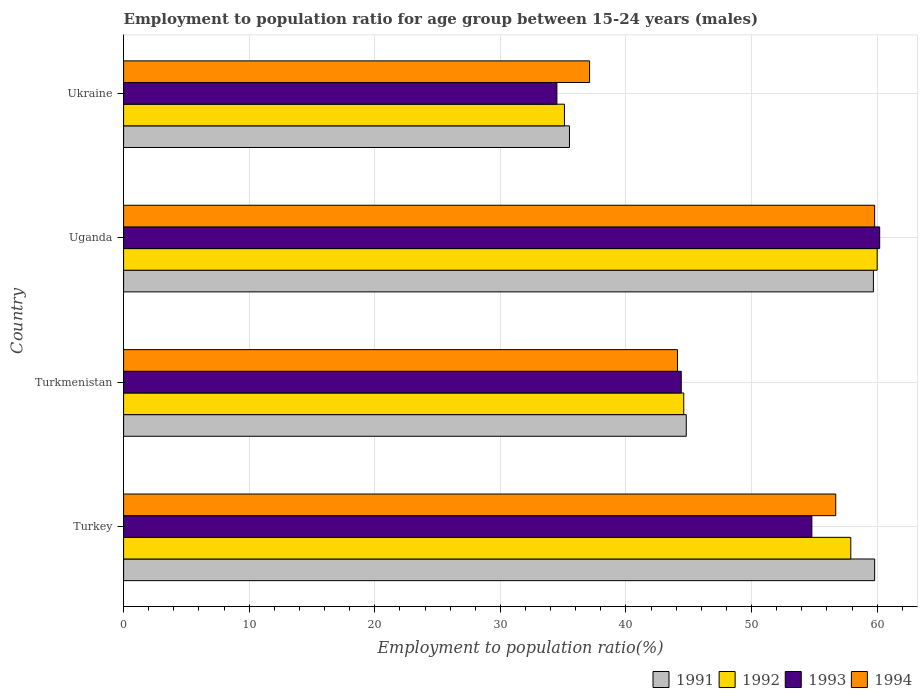Are the number of bars per tick equal to the number of legend labels?
Ensure brevity in your answer.  Yes. How many bars are there on the 4th tick from the top?
Offer a terse response. 4. How many bars are there on the 3rd tick from the bottom?
Your answer should be very brief. 4. What is the label of the 2nd group of bars from the top?
Your answer should be very brief. Uganda. In how many cases, is the number of bars for a given country not equal to the number of legend labels?
Give a very brief answer. 0. What is the employment to population ratio in 1992 in Turkmenistan?
Your answer should be compact. 44.6. Across all countries, what is the maximum employment to population ratio in 1992?
Keep it short and to the point. 60. Across all countries, what is the minimum employment to population ratio in 1991?
Provide a short and direct response. 35.5. In which country was the employment to population ratio in 1994 maximum?
Provide a succinct answer. Uganda. In which country was the employment to population ratio in 1991 minimum?
Your response must be concise. Ukraine. What is the total employment to population ratio in 1991 in the graph?
Your answer should be very brief. 199.8. What is the difference between the employment to population ratio in 1991 in Turkmenistan and that in Ukraine?
Offer a terse response. 9.3. What is the difference between the employment to population ratio in 1991 in Uganda and the employment to population ratio in 1994 in Turkmenistan?
Your response must be concise. 15.6. What is the average employment to population ratio in 1993 per country?
Your answer should be very brief. 48.48. What is the ratio of the employment to population ratio in 1991 in Turkey to that in Turkmenistan?
Ensure brevity in your answer.  1.33. Is the difference between the employment to population ratio in 1992 in Turkmenistan and Ukraine greater than the difference between the employment to population ratio in 1994 in Turkmenistan and Ukraine?
Keep it short and to the point. Yes. What is the difference between the highest and the second highest employment to population ratio in 1991?
Give a very brief answer. 0.1. What is the difference between the highest and the lowest employment to population ratio in 1992?
Provide a succinct answer. 24.9. In how many countries, is the employment to population ratio in 1993 greater than the average employment to population ratio in 1993 taken over all countries?
Your response must be concise. 2. Is the sum of the employment to population ratio in 1993 in Turkey and Uganda greater than the maximum employment to population ratio in 1992 across all countries?
Make the answer very short. Yes. Is it the case that in every country, the sum of the employment to population ratio in 1994 and employment to population ratio in 1992 is greater than the sum of employment to population ratio in 1991 and employment to population ratio in 1993?
Give a very brief answer. No. How many bars are there?
Give a very brief answer. 16. How many countries are there in the graph?
Give a very brief answer. 4. Are the values on the major ticks of X-axis written in scientific E-notation?
Your response must be concise. No. Does the graph contain any zero values?
Keep it short and to the point. No. Does the graph contain grids?
Ensure brevity in your answer.  Yes. Where does the legend appear in the graph?
Provide a short and direct response. Bottom right. How many legend labels are there?
Your answer should be very brief. 4. What is the title of the graph?
Offer a very short reply. Employment to population ratio for age group between 15-24 years (males). What is the label or title of the X-axis?
Provide a short and direct response. Employment to population ratio(%). What is the Employment to population ratio(%) of 1991 in Turkey?
Your answer should be very brief. 59.8. What is the Employment to population ratio(%) of 1992 in Turkey?
Your answer should be very brief. 57.9. What is the Employment to population ratio(%) in 1993 in Turkey?
Keep it short and to the point. 54.8. What is the Employment to population ratio(%) of 1994 in Turkey?
Provide a succinct answer. 56.7. What is the Employment to population ratio(%) in 1991 in Turkmenistan?
Make the answer very short. 44.8. What is the Employment to population ratio(%) in 1992 in Turkmenistan?
Provide a short and direct response. 44.6. What is the Employment to population ratio(%) of 1993 in Turkmenistan?
Your answer should be compact. 44.4. What is the Employment to population ratio(%) of 1994 in Turkmenistan?
Offer a terse response. 44.1. What is the Employment to population ratio(%) of 1991 in Uganda?
Your answer should be very brief. 59.7. What is the Employment to population ratio(%) of 1992 in Uganda?
Ensure brevity in your answer.  60. What is the Employment to population ratio(%) in 1993 in Uganda?
Your response must be concise. 60.2. What is the Employment to population ratio(%) of 1994 in Uganda?
Make the answer very short. 59.8. What is the Employment to population ratio(%) in 1991 in Ukraine?
Give a very brief answer. 35.5. What is the Employment to population ratio(%) in 1992 in Ukraine?
Offer a terse response. 35.1. What is the Employment to population ratio(%) in 1993 in Ukraine?
Make the answer very short. 34.5. What is the Employment to population ratio(%) of 1994 in Ukraine?
Ensure brevity in your answer.  37.1. Across all countries, what is the maximum Employment to population ratio(%) in 1991?
Provide a short and direct response. 59.8. Across all countries, what is the maximum Employment to population ratio(%) in 1992?
Offer a very short reply. 60. Across all countries, what is the maximum Employment to population ratio(%) in 1993?
Your answer should be very brief. 60.2. Across all countries, what is the maximum Employment to population ratio(%) of 1994?
Make the answer very short. 59.8. Across all countries, what is the minimum Employment to population ratio(%) of 1991?
Your response must be concise. 35.5. Across all countries, what is the minimum Employment to population ratio(%) in 1992?
Make the answer very short. 35.1. Across all countries, what is the minimum Employment to population ratio(%) of 1993?
Provide a short and direct response. 34.5. Across all countries, what is the minimum Employment to population ratio(%) of 1994?
Ensure brevity in your answer.  37.1. What is the total Employment to population ratio(%) of 1991 in the graph?
Provide a short and direct response. 199.8. What is the total Employment to population ratio(%) in 1992 in the graph?
Provide a short and direct response. 197.6. What is the total Employment to population ratio(%) in 1993 in the graph?
Offer a terse response. 193.9. What is the total Employment to population ratio(%) of 1994 in the graph?
Make the answer very short. 197.7. What is the difference between the Employment to population ratio(%) of 1992 in Turkey and that in Turkmenistan?
Give a very brief answer. 13.3. What is the difference between the Employment to population ratio(%) of 1993 in Turkey and that in Turkmenistan?
Make the answer very short. 10.4. What is the difference between the Employment to population ratio(%) in 1992 in Turkey and that in Uganda?
Offer a terse response. -2.1. What is the difference between the Employment to population ratio(%) of 1993 in Turkey and that in Uganda?
Your response must be concise. -5.4. What is the difference between the Employment to population ratio(%) in 1991 in Turkey and that in Ukraine?
Your answer should be compact. 24.3. What is the difference between the Employment to population ratio(%) of 1992 in Turkey and that in Ukraine?
Provide a short and direct response. 22.8. What is the difference between the Employment to population ratio(%) of 1993 in Turkey and that in Ukraine?
Provide a short and direct response. 20.3. What is the difference between the Employment to population ratio(%) of 1994 in Turkey and that in Ukraine?
Provide a short and direct response. 19.6. What is the difference between the Employment to population ratio(%) in 1991 in Turkmenistan and that in Uganda?
Offer a terse response. -14.9. What is the difference between the Employment to population ratio(%) of 1992 in Turkmenistan and that in Uganda?
Ensure brevity in your answer.  -15.4. What is the difference between the Employment to population ratio(%) of 1993 in Turkmenistan and that in Uganda?
Offer a terse response. -15.8. What is the difference between the Employment to population ratio(%) in 1994 in Turkmenistan and that in Uganda?
Your response must be concise. -15.7. What is the difference between the Employment to population ratio(%) in 1994 in Turkmenistan and that in Ukraine?
Your answer should be compact. 7. What is the difference between the Employment to population ratio(%) of 1991 in Uganda and that in Ukraine?
Provide a short and direct response. 24.2. What is the difference between the Employment to population ratio(%) of 1992 in Uganda and that in Ukraine?
Give a very brief answer. 24.9. What is the difference between the Employment to population ratio(%) of 1993 in Uganda and that in Ukraine?
Offer a very short reply. 25.7. What is the difference between the Employment to population ratio(%) in 1994 in Uganda and that in Ukraine?
Offer a very short reply. 22.7. What is the difference between the Employment to population ratio(%) of 1991 in Turkey and the Employment to population ratio(%) of 1992 in Turkmenistan?
Provide a succinct answer. 15.2. What is the difference between the Employment to population ratio(%) of 1991 in Turkey and the Employment to population ratio(%) of 1993 in Turkmenistan?
Give a very brief answer. 15.4. What is the difference between the Employment to population ratio(%) of 1991 in Turkey and the Employment to population ratio(%) of 1994 in Turkmenistan?
Your answer should be compact. 15.7. What is the difference between the Employment to population ratio(%) in 1992 in Turkey and the Employment to population ratio(%) in 1993 in Turkmenistan?
Ensure brevity in your answer.  13.5. What is the difference between the Employment to population ratio(%) in 1991 in Turkey and the Employment to population ratio(%) in 1993 in Uganda?
Provide a succinct answer. -0.4. What is the difference between the Employment to population ratio(%) in 1991 in Turkey and the Employment to population ratio(%) in 1994 in Uganda?
Keep it short and to the point. 0. What is the difference between the Employment to population ratio(%) of 1992 in Turkey and the Employment to population ratio(%) of 1993 in Uganda?
Make the answer very short. -2.3. What is the difference between the Employment to population ratio(%) of 1992 in Turkey and the Employment to population ratio(%) of 1994 in Uganda?
Your answer should be very brief. -1.9. What is the difference between the Employment to population ratio(%) of 1991 in Turkey and the Employment to population ratio(%) of 1992 in Ukraine?
Provide a succinct answer. 24.7. What is the difference between the Employment to population ratio(%) of 1991 in Turkey and the Employment to population ratio(%) of 1993 in Ukraine?
Keep it short and to the point. 25.3. What is the difference between the Employment to population ratio(%) in 1991 in Turkey and the Employment to population ratio(%) in 1994 in Ukraine?
Your answer should be compact. 22.7. What is the difference between the Employment to population ratio(%) in 1992 in Turkey and the Employment to population ratio(%) in 1993 in Ukraine?
Offer a very short reply. 23.4. What is the difference between the Employment to population ratio(%) of 1992 in Turkey and the Employment to population ratio(%) of 1994 in Ukraine?
Ensure brevity in your answer.  20.8. What is the difference between the Employment to population ratio(%) of 1991 in Turkmenistan and the Employment to population ratio(%) of 1992 in Uganda?
Your response must be concise. -15.2. What is the difference between the Employment to population ratio(%) of 1991 in Turkmenistan and the Employment to population ratio(%) of 1993 in Uganda?
Provide a succinct answer. -15.4. What is the difference between the Employment to population ratio(%) of 1991 in Turkmenistan and the Employment to population ratio(%) of 1994 in Uganda?
Offer a terse response. -15. What is the difference between the Employment to population ratio(%) in 1992 in Turkmenistan and the Employment to population ratio(%) in 1993 in Uganda?
Your response must be concise. -15.6. What is the difference between the Employment to population ratio(%) in 1992 in Turkmenistan and the Employment to population ratio(%) in 1994 in Uganda?
Your answer should be very brief. -15.2. What is the difference between the Employment to population ratio(%) in 1993 in Turkmenistan and the Employment to population ratio(%) in 1994 in Uganda?
Your answer should be very brief. -15.4. What is the difference between the Employment to population ratio(%) of 1991 in Turkmenistan and the Employment to population ratio(%) of 1992 in Ukraine?
Give a very brief answer. 9.7. What is the difference between the Employment to population ratio(%) in 1991 in Turkmenistan and the Employment to population ratio(%) in 1993 in Ukraine?
Your response must be concise. 10.3. What is the difference between the Employment to population ratio(%) in 1993 in Turkmenistan and the Employment to population ratio(%) in 1994 in Ukraine?
Your answer should be compact. 7.3. What is the difference between the Employment to population ratio(%) of 1991 in Uganda and the Employment to population ratio(%) of 1992 in Ukraine?
Make the answer very short. 24.6. What is the difference between the Employment to population ratio(%) in 1991 in Uganda and the Employment to population ratio(%) in 1993 in Ukraine?
Make the answer very short. 25.2. What is the difference between the Employment to population ratio(%) in 1991 in Uganda and the Employment to population ratio(%) in 1994 in Ukraine?
Offer a very short reply. 22.6. What is the difference between the Employment to population ratio(%) in 1992 in Uganda and the Employment to population ratio(%) in 1993 in Ukraine?
Your answer should be compact. 25.5. What is the difference between the Employment to population ratio(%) in 1992 in Uganda and the Employment to population ratio(%) in 1994 in Ukraine?
Your answer should be compact. 22.9. What is the difference between the Employment to population ratio(%) in 1993 in Uganda and the Employment to population ratio(%) in 1994 in Ukraine?
Your answer should be very brief. 23.1. What is the average Employment to population ratio(%) in 1991 per country?
Your answer should be compact. 49.95. What is the average Employment to population ratio(%) in 1992 per country?
Your response must be concise. 49.4. What is the average Employment to population ratio(%) in 1993 per country?
Your response must be concise. 48.48. What is the average Employment to population ratio(%) of 1994 per country?
Offer a very short reply. 49.42. What is the difference between the Employment to population ratio(%) in 1991 and Employment to population ratio(%) in 1993 in Turkey?
Your answer should be very brief. 5. What is the difference between the Employment to population ratio(%) in 1991 and Employment to population ratio(%) in 1994 in Turkey?
Your response must be concise. 3.1. What is the difference between the Employment to population ratio(%) in 1992 and Employment to population ratio(%) in 1993 in Turkey?
Your answer should be compact. 3.1. What is the difference between the Employment to population ratio(%) of 1991 and Employment to population ratio(%) of 1993 in Turkmenistan?
Ensure brevity in your answer.  0.4. What is the difference between the Employment to population ratio(%) of 1991 and Employment to population ratio(%) of 1994 in Turkmenistan?
Make the answer very short. 0.7. What is the difference between the Employment to population ratio(%) in 1992 and Employment to population ratio(%) in 1993 in Turkmenistan?
Keep it short and to the point. 0.2. What is the difference between the Employment to population ratio(%) in 1993 and Employment to population ratio(%) in 1994 in Turkmenistan?
Provide a short and direct response. 0.3. What is the difference between the Employment to population ratio(%) of 1991 and Employment to population ratio(%) of 1993 in Uganda?
Ensure brevity in your answer.  -0.5. What is the difference between the Employment to population ratio(%) of 1991 and Employment to population ratio(%) of 1992 in Ukraine?
Provide a short and direct response. 0.4. What is the difference between the Employment to population ratio(%) in 1991 and Employment to population ratio(%) in 1993 in Ukraine?
Keep it short and to the point. 1. What is the difference between the Employment to population ratio(%) of 1992 and Employment to population ratio(%) of 1994 in Ukraine?
Make the answer very short. -2. What is the difference between the Employment to population ratio(%) in 1993 and Employment to population ratio(%) in 1994 in Ukraine?
Make the answer very short. -2.6. What is the ratio of the Employment to population ratio(%) of 1991 in Turkey to that in Turkmenistan?
Provide a succinct answer. 1.33. What is the ratio of the Employment to population ratio(%) of 1992 in Turkey to that in Turkmenistan?
Your response must be concise. 1.3. What is the ratio of the Employment to population ratio(%) in 1993 in Turkey to that in Turkmenistan?
Ensure brevity in your answer.  1.23. What is the ratio of the Employment to population ratio(%) in 1994 in Turkey to that in Turkmenistan?
Your answer should be very brief. 1.29. What is the ratio of the Employment to population ratio(%) in 1993 in Turkey to that in Uganda?
Make the answer very short. 0.91. What is the ratio of the Employment to population ratio(%) of 1994 in Turkey to that in Uganda?
Offer a terse response. 0.95. What is the ratio of the Employment to population ratio(%) in 1991 in Turkey to that in Ukraine?
Offer a very short reply. 1.68. What is the ratio of the Employment to population ratio(%) in 1992 in Turkey to that in Ukraine?
Keep it short and to the point. 1.65. What is the ratio of the Employment to population ratio(%) in 1993 in Turkey to that in Ukraine?
Your response must be concise. 1.59. What is the ratio of the Employment to population ratio(%) in 1994 in Turkey to that in Ukraine?
Offer a very short reply. 1.53. What is the ratio of the Employment to population ratio(%) of 1991 in Turkmenistan to that in Uganda?
Provide a succinct answer. 0.75. What is the ratio of the Employment to population ratio(%) in 1992 in Turkmenistan to that in Uganda?
Your response must be concise. 0.74. What is the ratio of the Employment to population ratio(%) in 1993 in Turkmenistan to that in Uganda?
Give a very brief answer. 0.74. What is the ratio of the Employment to population ratio(%) in 1994 in Turkmenistan to that in Uganda?
Your answer should be compact. 0.74. What is the ratio of the Employment to population ratio(%) in 1991 in Turkmenistan to that in Ukraine?
Provide a short and direct response. 1.26. What is the ratio of the Employment to population ratio(%) in 1992 in Turkmenistan to that in Ukraine?
Your answer should be compact. 1.27. What is the ratio of the Employment to population ratio(%) of 1993 in Turkmenistan to that in Ukraine?
Offer a terse response. 1.29. What is the ratio of the Employment to population ratio(%) in 1994 in Turkmenistan to that in Ukraine?
Offer a terse response. 1.19. What is the ratio of the Employment to population ratio(%) of 1991 in Uganda to that in Ukraine?
Offer a terse response. 1.68. What is the ratio of the Employment to population ratio(%) of 1992 in Uganda to that in Ukraine?
Offer a very short reply. 1.71. What is the ratio of the Employment to population ratio(%) in 1993 in Uganda to that in Ukraine?
Your answer should be very brief. 1.74. What is the ratio of the Employment to population ratio(%) in 1994 in Uganda to that in Ukraine?
Offer a terse response. 1.61. What is the difference between the highest and the second highest Employment to population ratio(%) of 1991?
Give a very brief answer. 0.1. What is the difference between the highest and the lowest Employment to population ratio(%) in 1991?
Offer a terse response. 24.3. What is the difference between the highest and the lowest Employment to population ratio(%) in 1992?
Your answer should be compact. 24.9. What is the difference between the highest and the lowest Employment to population ratio(%) in 1993?
Provide a succinct answer. 25.7. What is the difference between the highest and the lowest Employment to population ratio(%) of 1994?
Provide a succinct answer. 22.7. 